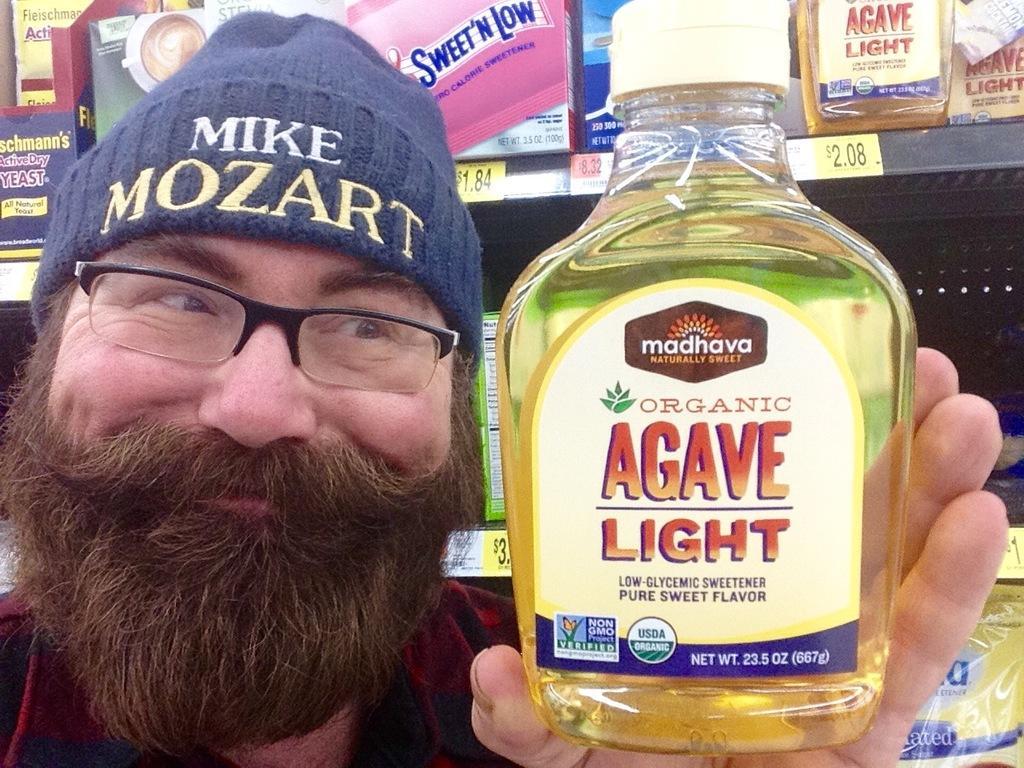Can you describe this image briefly? In this image there is a person and he is holding a bottle in the foreground. There is a metal rack with objects on it in the background. 